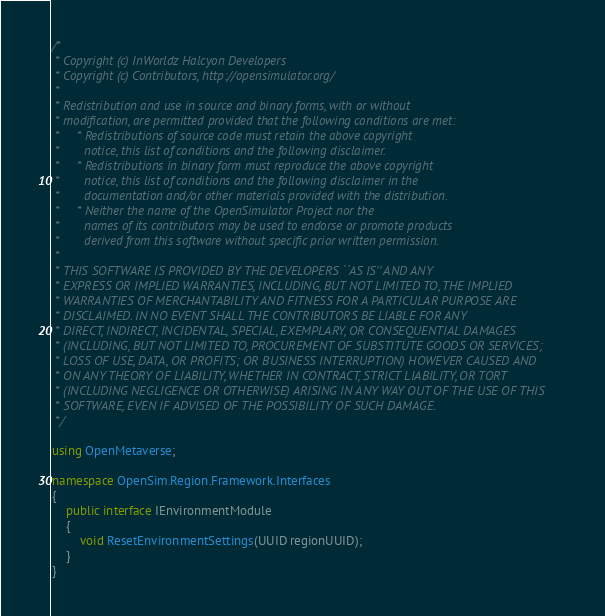Convert code to text. <code><loc_0><loc_0><loc_500><loc_500><_C#_>/*
 * Copyright (c) InWorldz Halcyon Developers
 * Copyright (c) Contributors, http://opensimulator.org/
 *
 * Redistribution and use in source and binary forms, with or without
 * modification, are permitted provided that the following conditions are met:
 *     * Redistributions of source code must retain the above copyright
 *       notice, this list of conditions and the following disclaimer.
 *     * Redistributions in binary form must reproduce the above copyright
 *       notice, this list of conditions and the following disclaimer in the
 *       documentation and/or other materials provided with the distribution.
 *     * Neither the name of the OpenSimulator Project nor the
 *       names of its contributors may be used to endorse or promote products
 *       derived from this software without specific prior written permission.
 *
 * THIS SOFTWARE IS PROVIDED BY THE DEVELOPERS ``AS IS'' AND ANY
 * EXPRESS OR IMPLIED WARRANTIES, INCLUDING, BUT NOT LIMITED TO, THE IMPLIED
 * WARRANTIES OF MERCHANTABILITY AND FITNESS FOR A PARTICULAR PURPOSE ARE
 * DISCLAIMED. IN NO EVENT SHALL THE CONTRIBUTORS BE LIABLE FOR ANY
 * DIRECT, INDIRECT, INCIDENTAL, SPECIAL, EXEMPLARY, OR CONSEQUENTIAL DAMAGES
 * (INCLUDING, BUT NOT LIMITED TO, PROCUREMENT OF SUBSTITUTE GOODS OR SERVICES;
 * LOSS OF USE, DATA, OR PROFITS; OR BUSINESS INTERRUPTION) HOWEVER CAUSED AND
 * ON ANY THEORY OF LIABILITY, WHETHER IN CONTRACT, STRICT LIABILITY, OR TORT
 * (INCLUDING NEGLIGENCE OR OTHERWISE) ARISING IN ANY WAY OUT OF THE USE OF THIS
 * SOFTWARE, EVEN IF ADVISED OF THE POSSIBILITY OF SUCH DAMAGE.
 */

using OpenMetaverse;

namespace OpenSim.Region.Framework.Interfaces
{
    public interface IEnvironmentModule
    {
        void ResetEnvironmentSettings(UUID regionUUID);
    }
}
</code> 